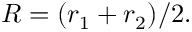<formula> <loc_0><loc_0><loc_500><loc_500>R = ( r _ { 1 } + r _ { 2 } ) / 2 .</formula> 